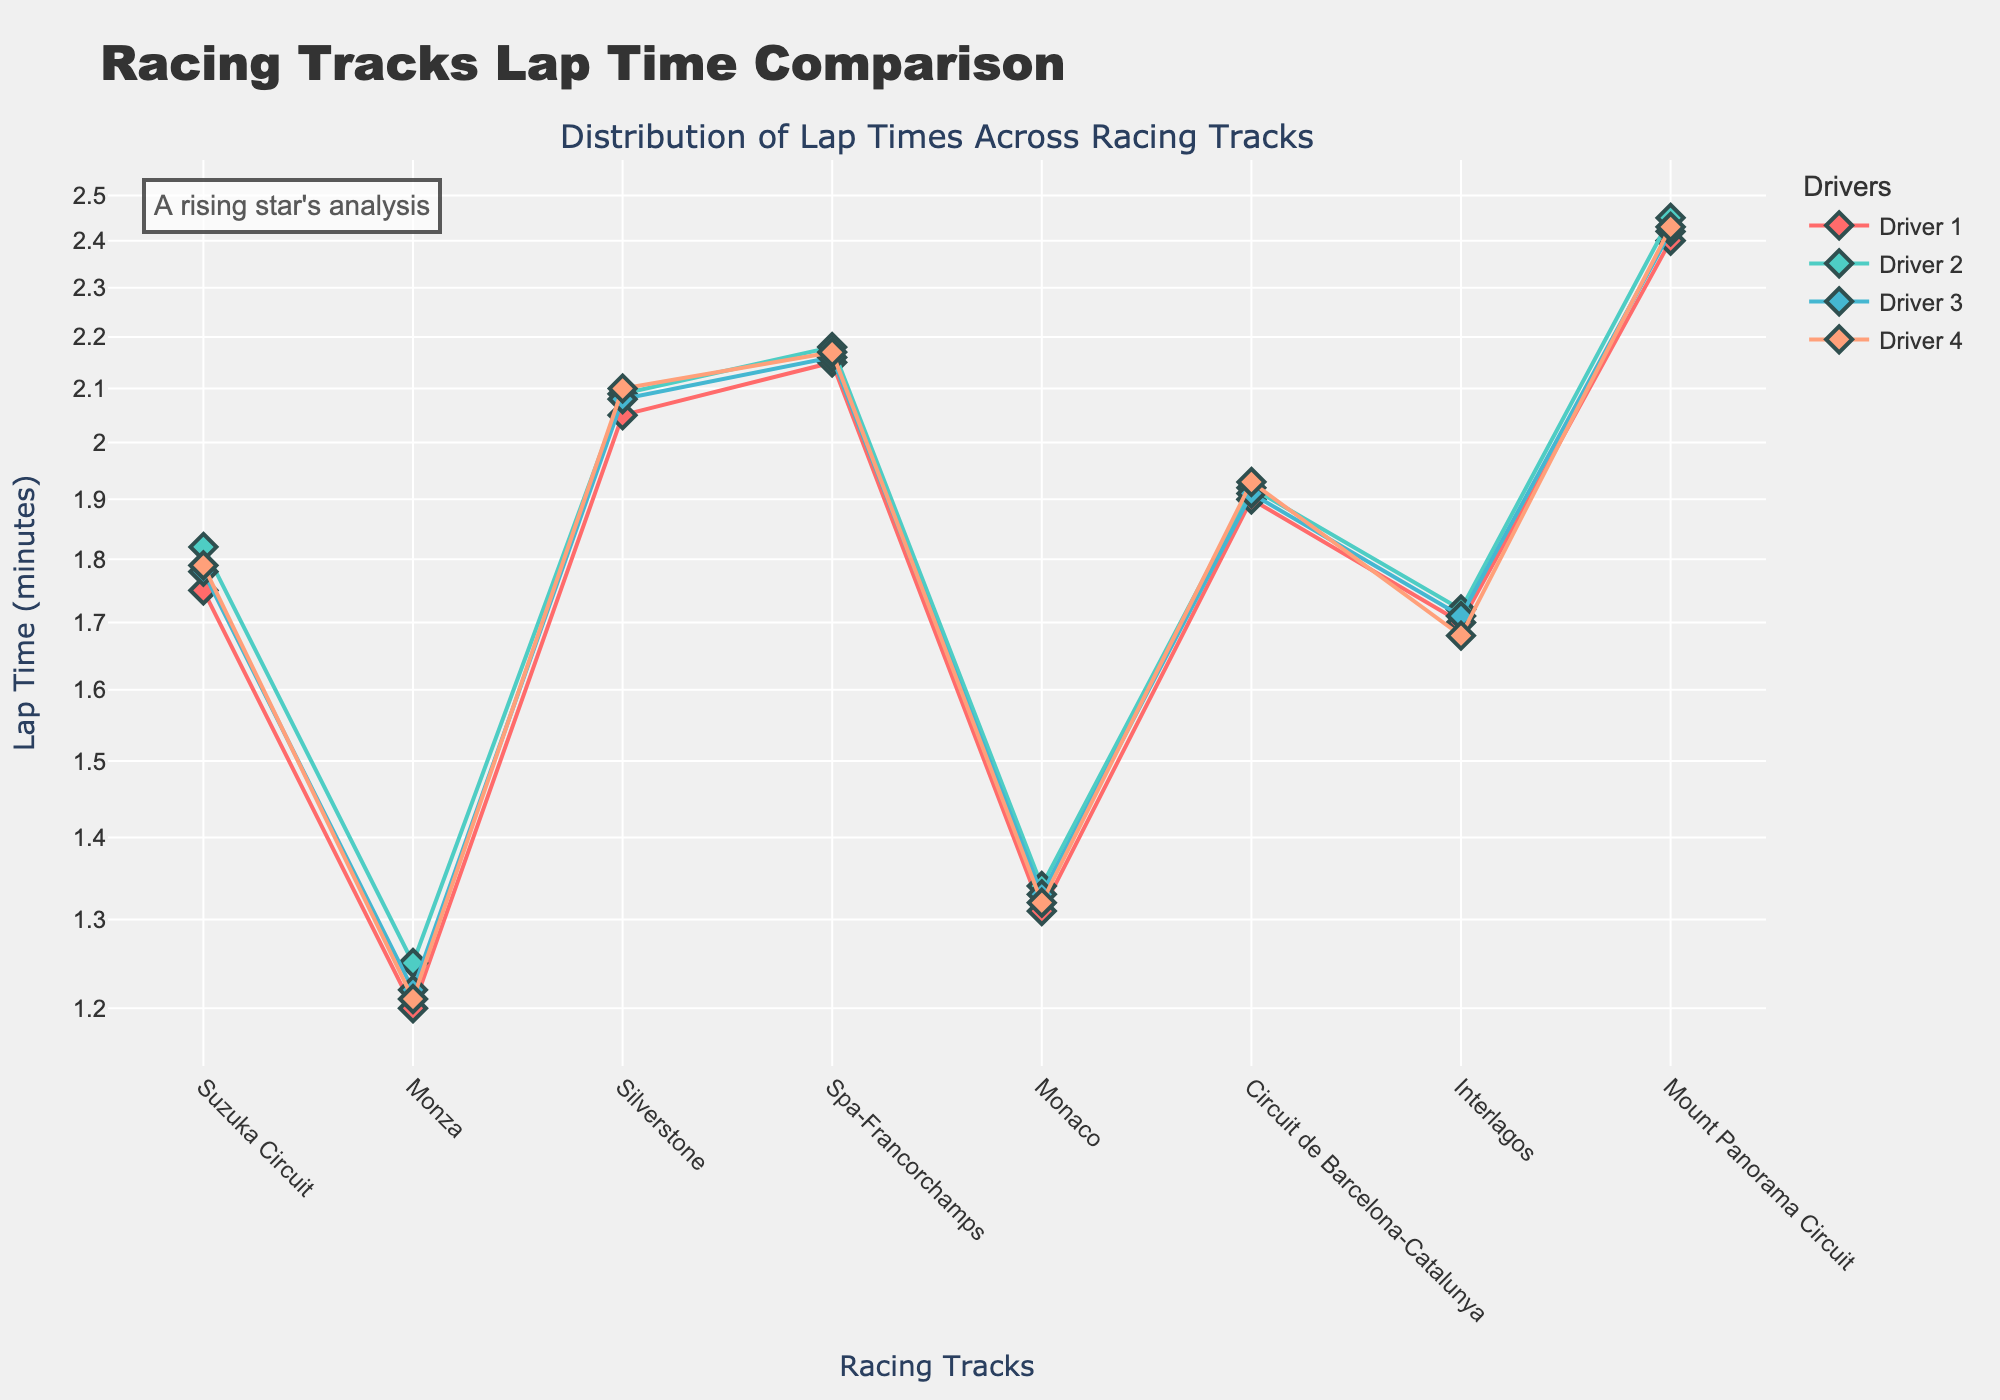What's the title of the figure? The title is prominently displayed at the top of the chart. It provides a summary of what the figure represents, which is "Racing Tracks Lap Time Comparison."
Answer: Racing Tracks Lap Time Comparison How are the lap times for different tracks visually distinguished? The lap times for different tracks are plotted with different colors and markers for each driver. There are four distinct colors and symbols representing each driver: red, green, blue, and salmon.
Answer: By using different colors and markers for each driver Which driver has the fastest lap time at Mount Panorama Circuit? By examining the y-axis values for the "Mount Panorama Circuit" track, the lowest point corresponds to Driver 1.
Answer: Driver 1 How does the lap time for Driver 2 at Monza compare to the lap time for Driver 4 at Suzuka Circuit? By checking the y-axis values for the respective drivers and tracks, Driver 2 at Monza has a lap time of 1.25 minutes, while Driver 4 at Suzuka Circuit has a lap time of 1.79 minutes.
Answer: Driver 2 at Monza is faster What's the range of lap times for Driver 3 across all tracks? To find the range, identify the highest and lowest lap times for Driver 3. The lowest lap time for Driver 3 is at Monza (1.22 minutes), and the highest is at Mount Panorama Circuit (2.42 minutes). The range is 2.42 - 1.22.
Answer: 1.20 minutes Which track exhibits the most consistent lap times among all drivers? Consistency can be evaluated by looking at the spread of lap times across drivers for each track. The track with the smallest spread between the maximum and minimum lap times is Interlagos (1.70 to 1.72).
Answer: Interlagos How does the lap time at Monaco for Driver 1 compare relative to the lap time at Monza for Driver 1? Evaluate how close the lap times are by comparing the values. Driver 1's lap time at Monaco is 1.31 minutes, while at Monza, it is 1.20 minutes. The lap time at Monaco is relatively longer.
Answer: Higher at Monaco What is the median lap time of all drivers at Silverstone? To determine the median, list out the lap times for Silverstone: 2.05, 2.08, 2.09, 2.10. The middle values are 2.08 and 2.09, so the median is (2.08 + 2.09) / 2.
Answer: 2.085 minutes What is the logarithmic difference in lap times between Suzuka Circuit for Driver 1 and Mount Panorama Circuit for Driver 1? Convert the lap times to their logarithmic values. For Suzuka Circuit (1.75) log10(1.75) ≈ 0.243, and for Mount Panorama Circuit (2.40) log10(2.40) ≈ 0.380. The difference is 0.380 - 0.243.
Answer: 0.137 